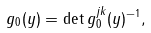<formula> <loc_0><loc_0><loc_500><loc_500>g _ { 0 } ( y ) = \det \| g _ { 0 } ^ { j k } ( y ) \| ^ { - 1 } ,</formula> 